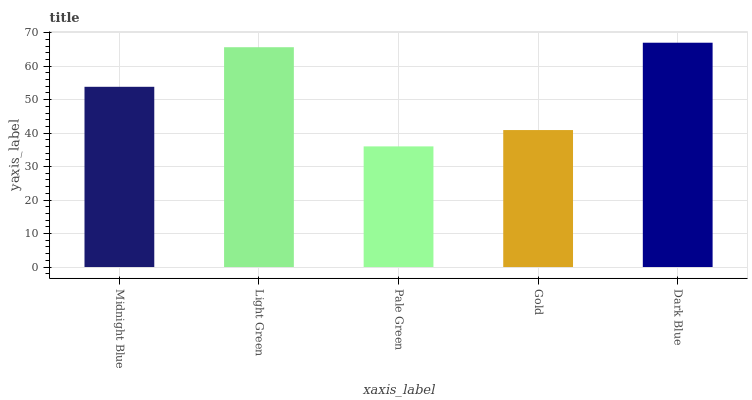Is Pale Green the minimum?
Answer yes or no. Yes. Is Dark Blue the maximum?
Answer yes or no. Yes. Is Light Green the minimum?
Answer yes or no. No. Is Light Green the maximum?
Answer yes or no. No. Is Light Green greater than Midnight Blue?
Answer yes or no. Yes. Is Midnight Blue less than Light Green?
Answer yes or no. Yes. Is Midnight Blue greater than Light Green?
Answer yes or no. No. Is Light Green less than Midnight Blue?
Answer yes or no. No. Is Midnight Blue the high median?
Answer yes or no. Yes. Is Midnight Blue the low median?
Answer yes or no. Yes. Is Gold the high median?
Answer yes or no. No. Is Pale Green the low median?
Answer yes or no. No. 